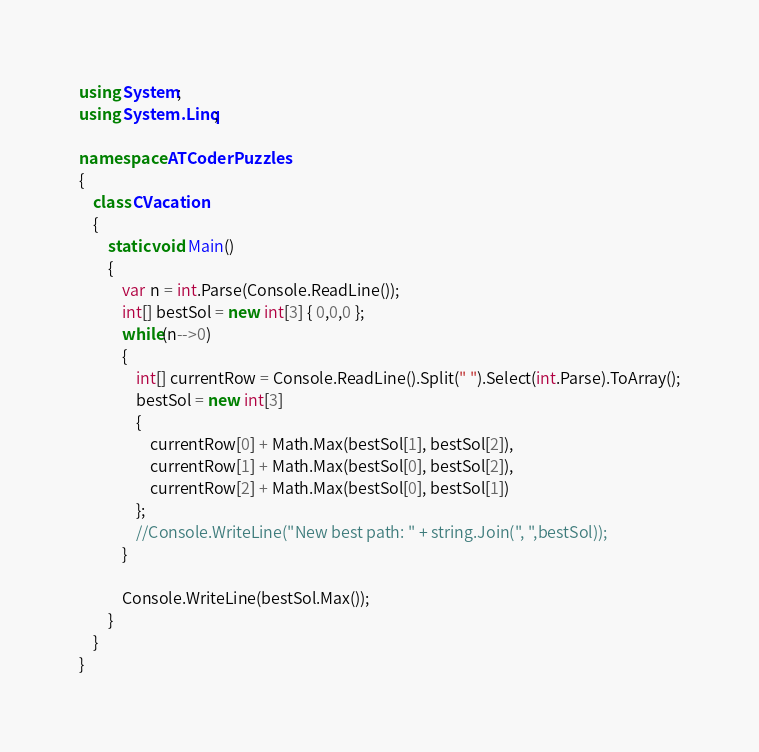Convert code to text. <code><loc_0><loc_0><loc_500><loc_500><_C#_>using System;
using System.Linq;

namespace ATCoderPuzzles
{
    class CVacation
    {
        static void Main()
        {
            var n = int.Parse(Console.ReadLine());
            int[] bestSol = new int[3] { 0,0,0 };
            while(n-->0)
            {
                int[] currentRow = Console.ReadLine().Split(" ").Select(int.Parse).ToArray();
                bestSol = new int[3]
                {
                    currentRow[0] + Math.Max(bestSol[1], bestSol[2]),
                    currentRow[1] + Math.Max(bestSol[0], bestSol[2]),
                    currentRow[2] + Math.Max(bestSol[0], bestSol[1])
                };
                //Console.WriteLine("New best path: " + string.Join(", ",bestSol));
            }
            
            Console.WriteLine(bestSol.Max());
        }
    }
}
</code> 